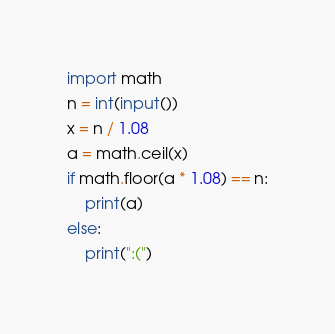<code> <loc_0><loc_0><loc_500><loc_500><_Python_>import math
n = int(input())
x = n / 1.08
a = math.ceil(x)
if math.floor(a * 1.08) == n:
	print(a)
else:
	print(":(")</code> 